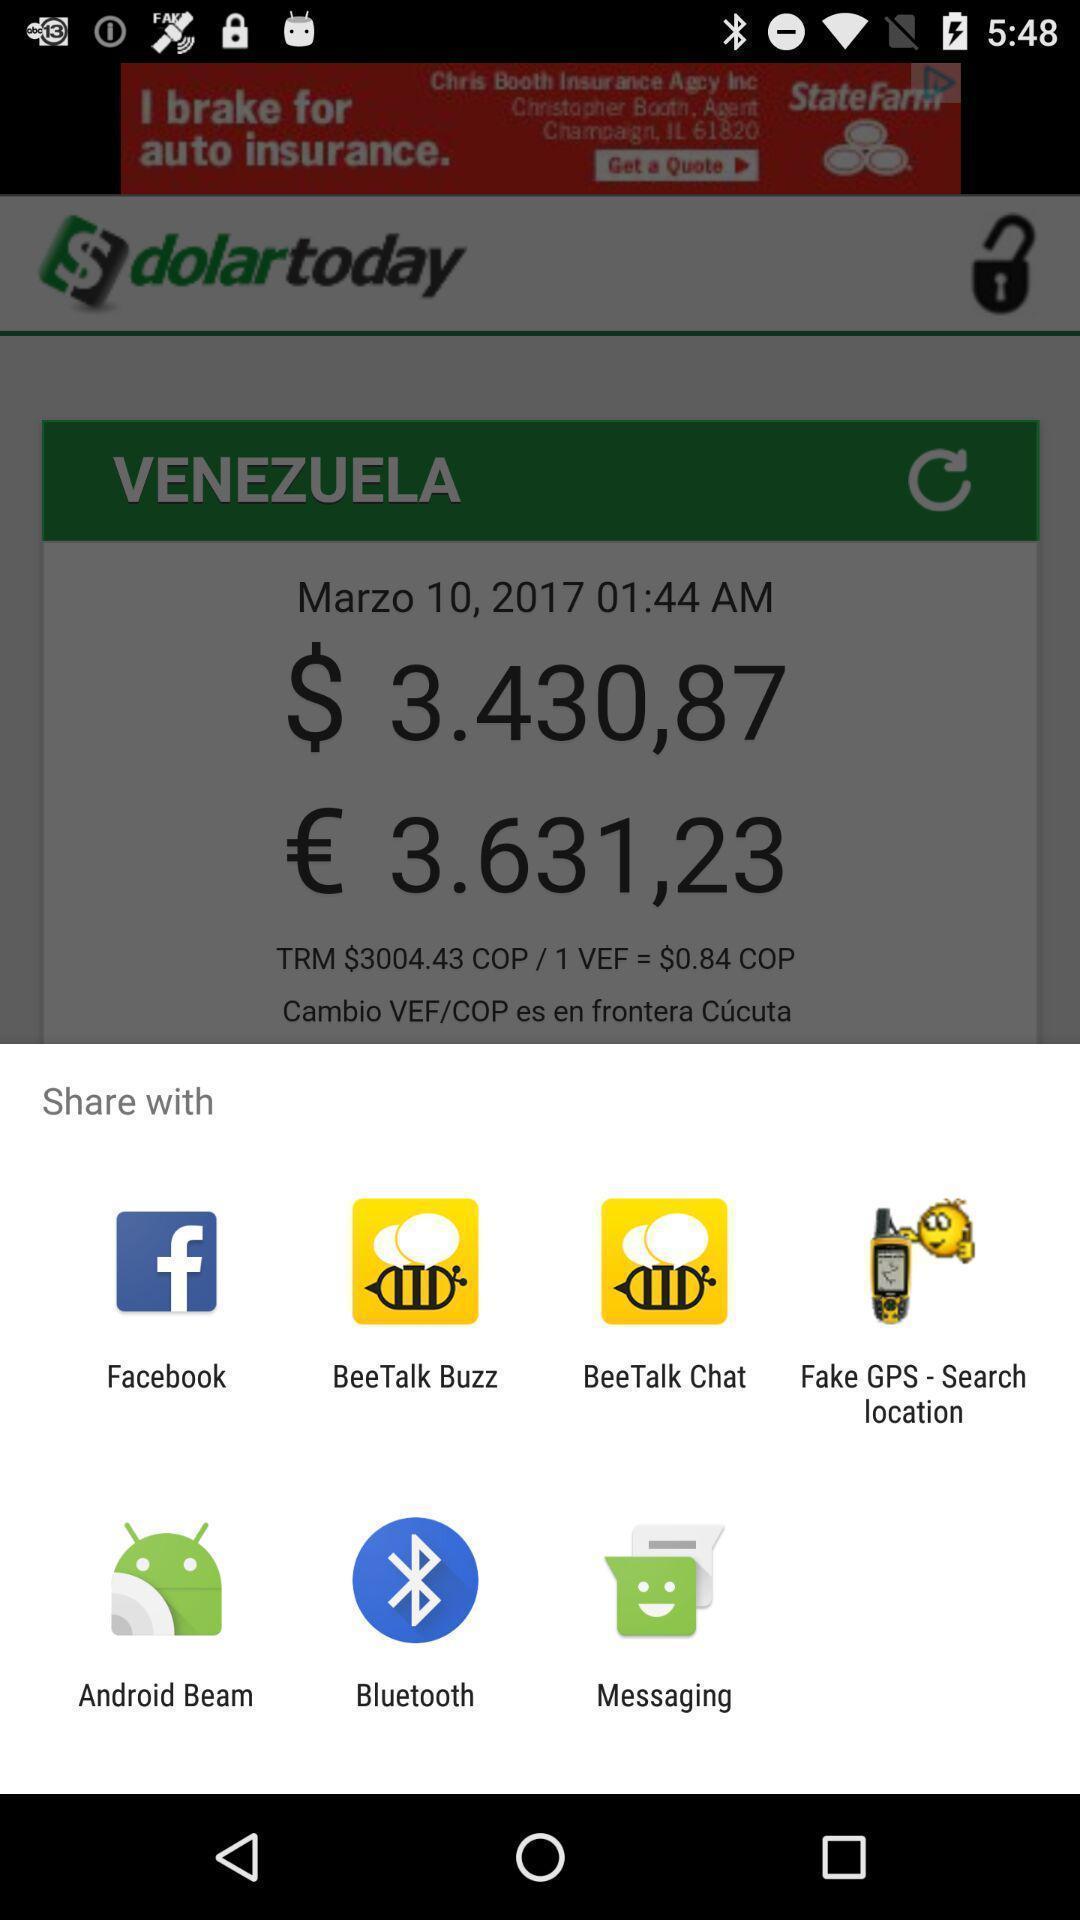Provide a detailed account of this screenshot. Popup of applications to share the information. 